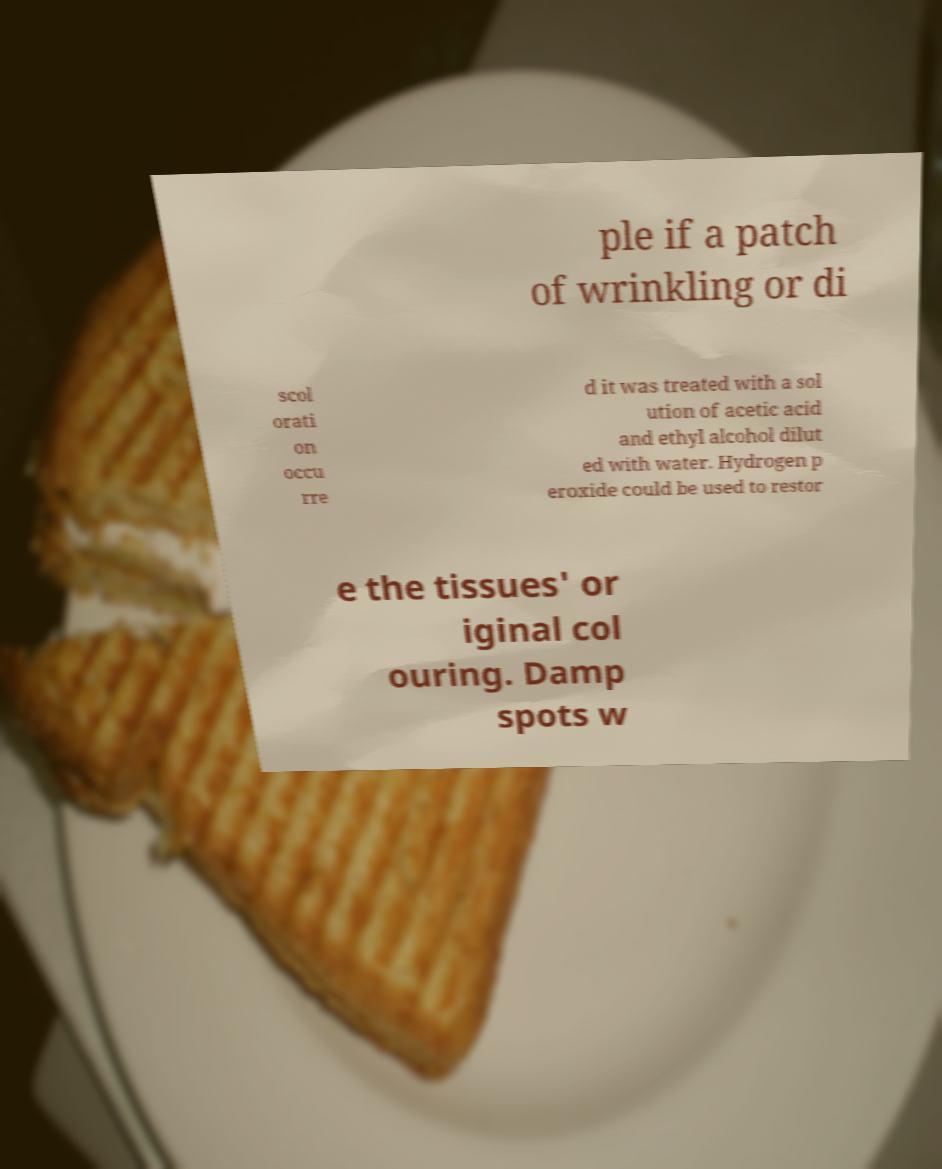Please identify and transcribe the text found in this image. ple if a patch of wrinkling or di scol orati on occu rre d it was treated with a sol ution of acetic acid and ethyl alcohol dilut ed with water. Hydrogen p eroxide could be used to restor e the tissues' or iginal col ouring. Damp spots w 